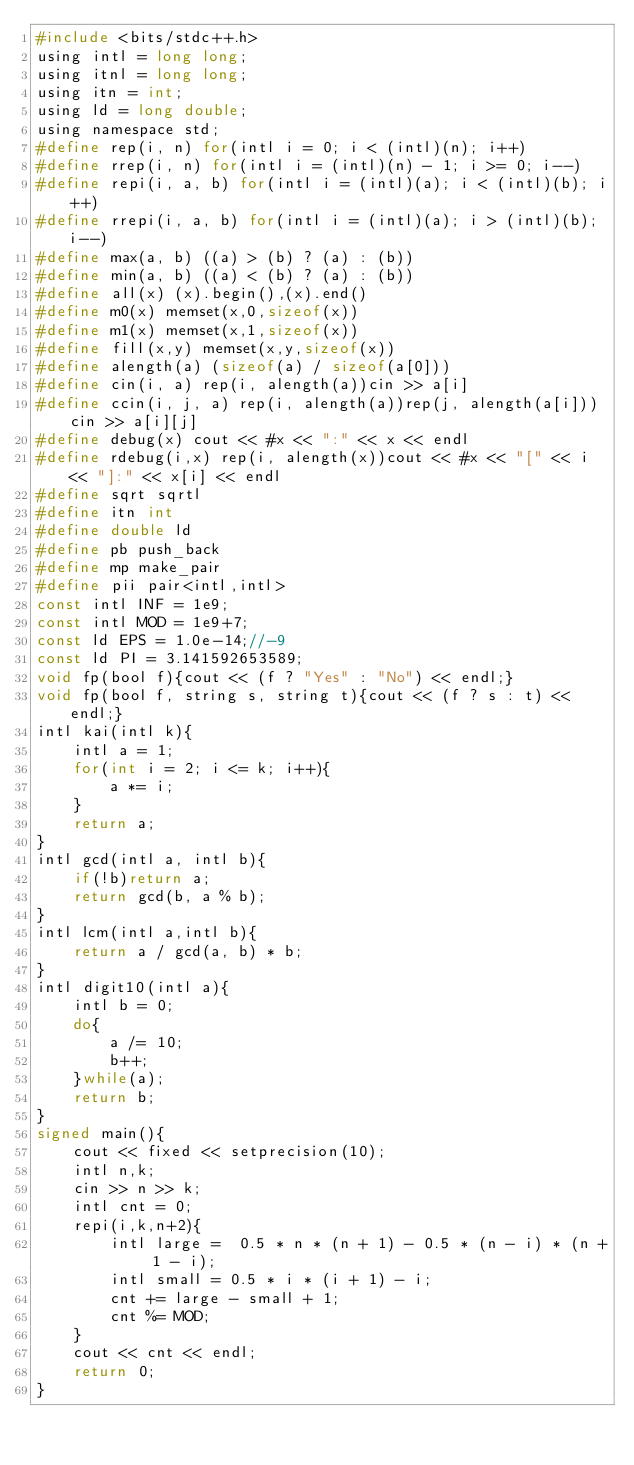Convert code to text. <code><loc_0><loc_0><loc_500><loc_500><_C_>#include <bits/stdc++.h>
using intl = long long;
using itnl = long long;
using itn = int;
using ld = long double;
using namespace std;
#define rep(i, n) for(intl i = 0; i < (intl)(n); i++)
#define rrep(i, n) for(intl i = (intl)(n) - 1; i >= 0; i--)
#define repi(i, a, b) for(intl i = (intl)(a); i < (intl)(b); i++)
#define rrepi(i, a, b) for(intl i = (intl)(a); i > (intl)(b); i--)
#define max(a, b) ((a) > (b) ? (a) : (b))
#define min(a, b) ((a) < (b) ? (a) : (b))
#define all(x) (x).begin(),(x).end()
#define m0(x) memset(x,0,sizeof(x))
#define m1(x) memset(x,1,sizeof(x))
#define fill(x,y) memset(x,y,sizeof(x))
#define alength(a) (sizeof(a) / sizeof(a[0]))
#define cin(i, a) rep(i, alength(a))cin >> a[i]
#define ccin(i, j, a) rep(i, alength(a))rep(j, alength(a[i]))cin >> a[i][j]
#define debug(x) cout << #x << ":" << x << endl
#define rdebug(i,x) rep(i, alength(x))cout << #x << "[" << i << "]:" << x[i] << endl
#define sqrt sqrtl
#define itn int
#define double ld
#define pb push_back
#define mp make_pair
#define pii pair<intl,intl>
const intl INF = 1e9;
const intl MOD = 1e9+7;
const ld EPS = 1.0e-14;//-9
const ld PI = 3.141592653589;
void fp(bool f){cout << (f ? "Yes" : "No") << endl;}
void fp(bool f, string s, string t){cout << (f ? s : t) << endl;}
intl kai(intl k){
    intl a = 1;
    for(int i = 2; i <= k; i++){
        a *= i;
    }
    return a;
}
intl gcd(intl a, intl b){
    if(!b)return a;
    return gcd(b, a % b);
}
intl lcm(intl a,intl b){
    return a / gcd(a, b) * b;
}
intl digit10(intl a){
    intl b = 0;
    do{
        a /= 10;
        b++;
    }while(a);
    return b;
}
signed main(){
    cout << fixed << setprecision(10);
    intl n,k;
    cin >> n >> k;
    intl cnt = 0;
    repi(i,k,n+2){
        intl large =  0.5 * n * (n + 1) - 0.5 * (n - i) * (n + 1 - i);
        intl small = 0.5 * i * (i + 1) - i;
        cnt += large - small + 1;
        cnt %= MOD;
    }
    cout << cnt << endl;
    return 0;
}</code> 